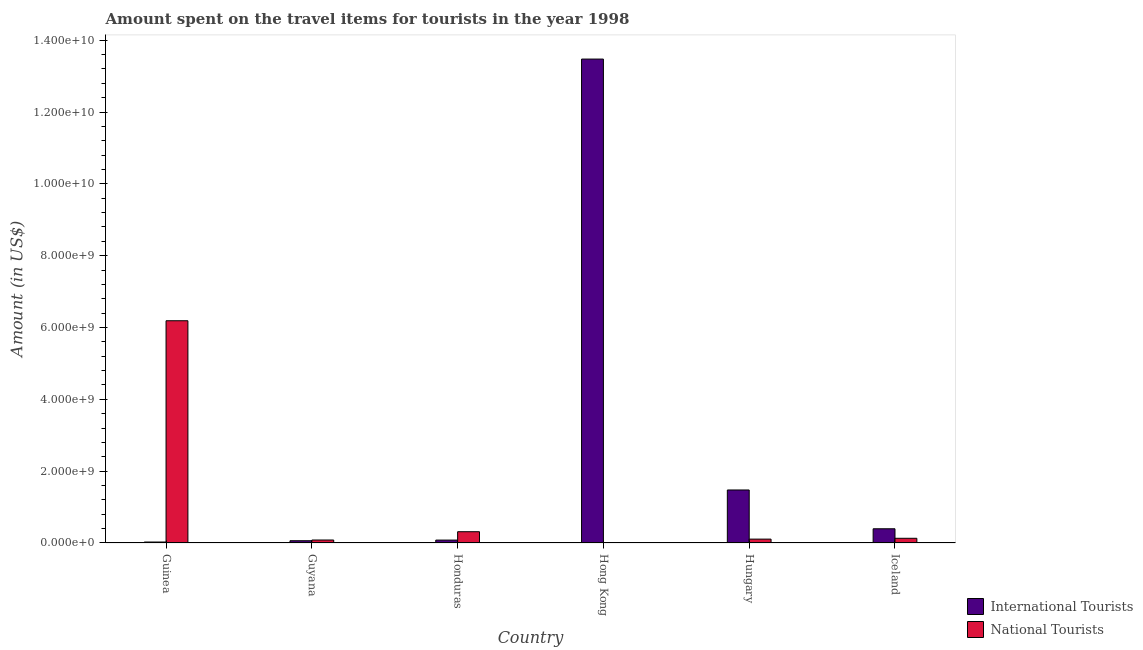How many groups of bars are there?
Your answer should be compact. 6. Are the number of bars per tick equal to the number of legend labels?
Offer a terse response. Yes. Are the number of bars on each tick of the X-axis equal?
Provide a short and direct response. Yes. How many bars are there on the 3rd tick from the left?
Give a very brief answer. 2. What is the label of the 2nd group of bars from the left?
Offer a very short reply. Guyana. In how many cases, is the number of bars for a given country not equal to the number of legend labels?
Offer a terse response. 0. What is the amount spent on travel items of national tourists in Hungary?
Keep it short and to the point. 1.08e+08. Across all countries, what is the maximum amount spent on travel items of international tourists?
Your response must be concise. 1.35e+1. Across all countries, what is the minimum amount spent on travel items of international tourists?
Your answer should be compact. 2.70e+07. In which country was the amount spent on travel items of international tourists maximum?
Keep it short and to the point. Hong Kong. In which country was the amount spent on travel items of national tourists minimum?
Provide a succinct answer. Hong Kong. What is the total amount spent on travel items of international tourists in the graph?
Offer a terse response. 1.55e+1. What is the difference between the amount spent on travel items of national tourists in Guinea and that in Hungary?
Provide a short and direct response. 6.08e+09. What is the difference between the amount spent on travel items of international tourists in Honduras and the amount spent on travel items of national tourists in Iceland?
Make the answer very short. -5.00e+07. What is the average amount spent on travel items of international tourists per country?
Provide a succinct answer. 2.59e+09. What is the difference between the amount spent on travel items of international tourists and amount spent on travel items of national tourists in Iceland?
Keep it short and to the point. 2.65e+08. In how many countries, is the amount spent on travel items of national tourists greater than 2400000000 US$?
Provide a short and direct response. 1. What is the ratio of the amount spent on travel items of international tourists in Guinea to that in Iceland?
Make the answer very short. 0.07. Is the difference between the amount spent on travel items of national tourists in Guinea and Honduras greater than the difference between the amount spent on travel items of international tourists in Guinea and Honduras?
Make the answer very short. Yes. What is the difference between the highest and the second highest amount spent on travel items of international tourists?
Provide a succinct answer. 1.20e+1. What is the difference between the highest and the lowest amount spent on travel items of international tourists?
Your response must be concise. 1.34e+1. What does the 1st bar from the left in Hungary represents?
Give a very brief answer. International Tourists. What does the 2nd bar from the right in Guyana represents?
Your answer should be compact. International Tourists. How many countries are there in the graph?
Offer a very short reply. 6. Does the graph contain any zero values?
Provide a succinct answer. No. Does the graph contain grids?
Your response must be concise. No. Where does the legend appear in the graph?
Your response must be concise. Bottom right. What is the title of the graph?
Give a very brief answer. Amount spent on the travel items for tourists in the year 1998. Does "Current US$" appear as one of the legend labels in the graph?
Offer a very short reply. No. What is the Amount (in US$) in International Tourists in Guinea?
Give a very brief answer. 2.70e+07. What is the Amount (in US$) in National Tourists in Guinea?
Your response must be concise. 6.19e+09. What is the Amount (in US$) of International Tourists in Guyana?
Your answer should be compact. 6.30e+07. What is the Amount (in US$) of National Tourists in Guyana?
Make the answer very short. 8.30e+07. What is the Amount (in US$) of International Tourists in Honduras?
Your response must be concise. 8.10e+07. What is the Amount (in US$) in National Tourists in Honduras?
Ensure brevity in your answer.  3.14e+08. What is the Amount (in US$) in International Tourists in Hong Kong?
Keep it short and to the point. 1.35e+1. What is the Amount (in US$) of International Tourists in Hungary?
Provide a succinct answer. 1.48e+09. What is the Amount (in US$) of National Tourists in Hungary?
Provide a succinct answer. 1.08e+08. What is the Amount (in US$) of International Tourists in Iceland?
Keep it short and to the point. 3.96e+08. What is the Amount (in US$) in National Tourists in Iceland?
Give a very brief answer. 1.31e+08. Across all countries, what is the maximum Amount (in US$) of International Tourists?
Give a very brief answer. 1.35e+1. Across all countries, what is the maximum Amount (in US$) in National Tourists?
Ensure brevity in your answer.  6.19e+09. Across all countries, what is the minimum Amount (in US$) in International Tourists?
Ensure brevity in your answer.  2.70e+07. Across all countries, what is the minimum Amount (in US$) of National Tourists?
Your answer should be very brief. 9.00e+05. What is the total Amount (in US$) of International Tourists in the graph?
Your answer should be compact. 1.55e+1. What is the total Amount (in US$) in National Tourists in the graph?
Provide a succinct answer. 6.82e+09. What is the difference between the Amount (in US$) of International Tourists in Guinea and that in Guyana?
Provide a short and direct response. -3.60e+07. What is the difference between the Amount (in US$) in National Tourists in Guinea and that in Guyana?
Keep it short and to the point. 6.10e+09. What is the difference between the Amount (in US$) of International Tourists in Guinea and that in Honduras?
Give a very brief answer. -5.40e+07. What is the difference between the Amount (in US$) of National Tourists in Guinea and that in Honduras?
Ensure brevity in your answer.  5.87e+09. What is the difference between the Amount (in US$) in International Tourists in Guinea and that in Hong Kong?
Offer a terse response. -1.34e+1. What is the difference between the Amount (in US$) of National Tourists in Guinea and that in Hong Kong?
Keep it short and to the point. 6.19e+09. What is the difference between the Amount (in US$) of International Tourists in Guinea and that in Hungary?
Offer a terse response. -1.45e+09. What is the difference between the Amount (in US$) in National Tourists in Guinea and that in Hungary?
Offer a terse response. 6.08e+09. What is the difference between the Amount (in US$) of International Tourists in Guinea and that in Iceland?
Provide a succinct answer. -3.69e+08. What is the difference between the Amount (in US$) in National Tourists in Guinea and that in Iceland?
Provide a succinct answer. 6.06e+09. What is the difference between the Amount (in US$) in International Tourists in Guyana and that in Honduras?
Offer a very short reply. -1.80e+07. What is the difference between the Amount (in US$) in National Tourists in Guyana and that in Honduras?
Provide a short and direct response. -2.31e+08. What is the difference between the Amount (in US$) of International Tourists in Guyana and that in Hong Kong?
Provide a short and direct response. -1.34e+1. What is the difference between the Amount (in US$) of National Tourists in Guyana and that in Hong Kong?
Your answer should be compact. 8.21e+07. What is the difference between the Amount (in US$) in International Tourists in Guyana and that in Hungary?
Provide a short and direct response. -1.41e+09. What is the difference between the Amount (in US$) in National Tourists in Guyana and that in Hungary?
Your answer should be very brief. -2.50e+07. What is the difference between the Amount (in US$) in International Tourists in Guyana and that in Iceland?
Give a very brief answer. -3.33e+08. What is the difference between the Amount (in US$) of National Tourists in Guyana and that in Iceland?
Your answer should be very brief. -4.80e+07. What is the difference between the Amount (in US$) of International Tourists in Honduras and that in Hong Kong?
Your response must be concise. -1.34e+1. What is the difference between the Amount (in US$) in National Tourists in Honduras and that in Hong Kong?
Make the answer very short. 3.13e+08. What is the difference between the Amount (in US$) of International Tourists in Honduras and that in Hungary?
Ensure brevity in your answer.  -1.40e+09. What is the difference between the Amount (in US$) in National Tourists in Honduras and that in Hungary?
Provide a succinct answer. 2.06e+08. What is the difference between the Amount (in US$) in International Tourists in Honduras and that in Iceland?
Keep it short and to the point. -3.15e+08. What is the difference between the Amount (in US$) of National Tourists in Honduras and that in Iceland?
Make the answer very short. 1.83e+08. What is the difference between the Amount (in US$) of International Tourists in Hong Kong and that in Hungary?
Your answer should be very brief. 1.20e+1. What is the difference between the Amount (in US$) in National Tourists in Hong Kong and that in Hungary?
Provide a short and direct response. -1.07e+08. What is the difference between the Amount (in US$) of International Tourists in Hong Kong and that in Iceland?
Offer a very short reply. 1.31e+1. What is the difference between the Amount (in US$) of National Tourists in Hong Kong and that in Iceland?
Provide a succinct answer. -1.30e+08. What is the difference between the Amount (in US$) in International Tourists in Hungary and that in Iceland?
Provide a short and direct response. 1.08e+09. What is the difference between the Amount (in US$) in National Tourists in Hungary and that in Iceland?
Offer a very short reply. -2.30e+07. What is the difference between the Amount (in US$) in International Tourists in Guinea and the Amount (in US$) in National Tourists in Guyana?
Ensure brevity in your answer.  -5.60e+07. What is the difference between the Amount (in US$) of International Tourists in Guinea and the Amount (in US$) of National Tourists in Honduras?
Offer a very short reply. -2.87e+08. What is the difference between the Amount (in US$) of International Tourists in Guinea and the Amount (in US$) of National Tourists in Hong Kong?
Give a very brief answer. 2.61e+07. What is the difference between the Amount (in US$) of International Tourists in Guinea and the Amount (in US$) of National Tourists in Hungary?
Ensure brevity in your answer.  -8.10e+07. What is the difference between the Amount (in US$) of International Tourists in Guinea and the Amount (in US$) of National Tourists in Iceland?
Provide a succinct answer. -1.04e+08. What is the difference between the Amount (in US$) of International Tourists in Guyana and the Amount (in US$) of National Tourists in Honduras?
Give a very brief answer. -2.51e+08. What is the difference between the Amount (in US$) of International Tourists in Guyana and the Amount (in US$) of National Tourists in Hong Kong?
Offer a terse response. 6.21e+07. What is the difference between the Amount (in US$) of International Tourists in Guyana and the Amount (in US$) of National Tourists in Hungary?
Provide a succinct answer. -4.50e+07. What is the difference between the Amount (in US$) in International Tourists in Guyana and the Amount (in US$) in National Tourists in Iceland?
Your answer should be compact. -6.80e+07. What is the difference between the Amount (in US$) of International Tourists in Honduras and the Amount (in US$) of National Tourists in Hong Kong?
Make the answer very short. 8.01e+07. What is the difference between the Amount (in US$) of International Tourists in Honduras and the Amount (in US$) of National Tourists in Hungary?
Make the answer very short. -2.70e+07. What is the difference between the Amount (in US$) of International Tourists in Honduras and the Amount (in US$) of National Tourists in Iceland?
Your response must be concise. -5.00e+07. What is the difference between the Amount (in US$) in International Tourists in Hong Kong and the Amount (in US$) in National Tourists in Hungary?
Your answer should be compact. 1.34e+1. What is the difference between the Amount (in US$) in International Tourists in Hong Kong and the Amount (in US$) in National Tourists in Iceland?
Your answer should be compact. 1.33e+1. What is the difference between the Amount (in US$) in International Tourists in Hungary and the Amount (in US$) in National Tourists in Iceland?
Provide a succinct answer. 1.34e+09. What is the average Amount (in US$) in International Tourists per country?
Offer a terse response. 2.59e+09. What is the average Amount (in US$) of National Tourists per country?
Provide a short and direct response. 1.14e+09. What is the difference between the Amount (in US$) in International Tourists and Amount (in US$) in National Tourists in Guinea?
Make the answer very short. -6.16e+09. What is the difference between the Amount (in US$) of International Tourists and Amount (in US$) of National Tourists in Guyana?
Offer a terse response. -2.00e+07. What is the difference between the Amount (in US$) of International Tourists and Amount (in US$) of National Tourists in Honduras?
Keep it short and to the point. -2.33e+08. What is the difference between the Amount (in US$) of International Tourists and Amount (in US$) of National Tourists in Hong Kong?
Ensure brevity in your answer.  1.35e+1. What is the difference between the Amount (in US$) in International Tourists and Amount (in US$) in National Tourists in Hungary?
Provide a short and direct response. 1.37e+09. What is the difference between the Amount (in US$) in International Tourists and Amount (in US$) in National Tourists in Iceland?
Offer a very short reply. 2.65e+08. What is the ratio of the Amount (in US$) of International Tourists in Guinea to that in Guyana?
Your answer should be very brief. 0.43. What is the ratio of the Amount (in US$) in National Tourists in Guinea to that in Guyana?
Give a very brief answer. 74.55. What is the ratio of the Amount (in US$) in International Tourists in Guinea to that in Honduras?
Make the answer very short. 0.33. What is the ratio of the Amount (in US$) in National Tourists in Guinea to that in Honduras?
Offer a very short reply. 19.71. What is the ratio of the Amount (in US$) in International Tourists in Guinea to that in Hong Kong?
Give a very brief answer. 0. What is the ratio of the Amount (in US$) of National Tourists in Guinea to that in Hong Kong?
Your answer should be compact. 6875.56. What is the ratio of the Amount (in US$) in International Tourists in Guinea to that in Hungary?
Give a very brief answer. 0.02. What is the ratio of the Amount (in US$) of National Tourists in Guinea to that in Hungary?
Ensure brevity in your answer.  57.3. What is the ratio of the Amount (in US$) in International Tourists in Guinea to that in Iceland?
Your answer should be very brief. 0.07. What is the ratio of the Amount (in US$) of National Tourists in Guinea to that in Iceland?
Ensure brevity in your answer.  47.24. What is the ratio of the Amount (in US$) of National Tourists in Guyana to that in Honduras?
Offer a terse response. 0.26. What is the ratio of the Amount (in US$) in International Tourists in Guyana to that in Hong Kong?
Offer a terse response. 0. What is the ratio of the Amount (in US$) in National Tourists in Guyana to that in Hong Kong?
Your response must be concise. 92.22. What is the ratio of the Amount (in US$) in International Tourists in Guyana to that in Hungary?
Offer a very short reply. 0.04. What is the ratio of the Amount (in US$) of National Tourists in Guyana to that in Hungary?
Make the answer very short. 0.77. What is the ratio of the Amount (in US$) of International Tourists in Guyana to that in Iceland?
Your response must be concise. 0.16. What is the ratio of the Amount (in US$) of National Tourists in Guyana to that in Iceland?
Provide a succinct answer. 0.63. What is the ratio of the Amount (in US$) in International Tourists in Honduras to that in Hong Kong?
Offer a terse response. 0.01. What is the ratio of the Amount (in US$) in National Tourists in Honduras to that in Hong Kong?
Your answer should be very brief. 348.89. What is the ratio of the Amount (in US$) in International Tourists in Honduras to that in Hungary?
Keep it short and to the point. 0.05. What is the ratio of the Amount (in US$) in National Tourists in Honduras to that in Hungary?
Make the answer very short. 2.91. What is the ratio of the Amount (in US$) in International Tourists in Honduras to that in Iceland?
Keep it short and to the point. 0.2. What is the ratio of the Amount (in US$) in National Tourists in Honduras to that in Iceland?
Provide a succinct answer. 2.4. What is the ratio of the Amount (in US$) of International Tourists in Hong Kong to that in Hungary?
Your answer should be very brief. 9.13. What is the ratio of the Amount (in US$) in National Tourists in Hong Kong to that in Hungary?
Give a very brief answer. 0.01. What is the ratio of the Amount (in US$) in International Tourists in Hong Kong to that in Iceland?
Give a very brief answer. 34.03. What is the ratio of the Amount (in US$) of National Tourists in Hong Kong to that in Iceland?
Offer a very short reply. 0.01. What is the ratio of the Amount (in US$) in International Tourists in Hungary to that in Iceland?
Your response must be concise. 3.73. What is the ratio of the Amount (in US$) in National Tourists in Hungary to that in Iceland?
Offer a terse response. 0.82. What is the difference between the highest and the second highest Amount (in US$) of International Tourists?
Your answer should be compact. 1.20e+1. What is the difference between the highest and the second highest Amount (in US$) in National Tourists?
Ensure brevity in your answer.  5.87e+09. What is the difference between the highest and the lowest Amount (in US$) in International Tourists?
Ensure brevity in your answer.  1.34e+1. What is the difference between the highest and the lowest Amount (in US$) in National Tourists?
Provide a short and direct response. 6.19e+09. 